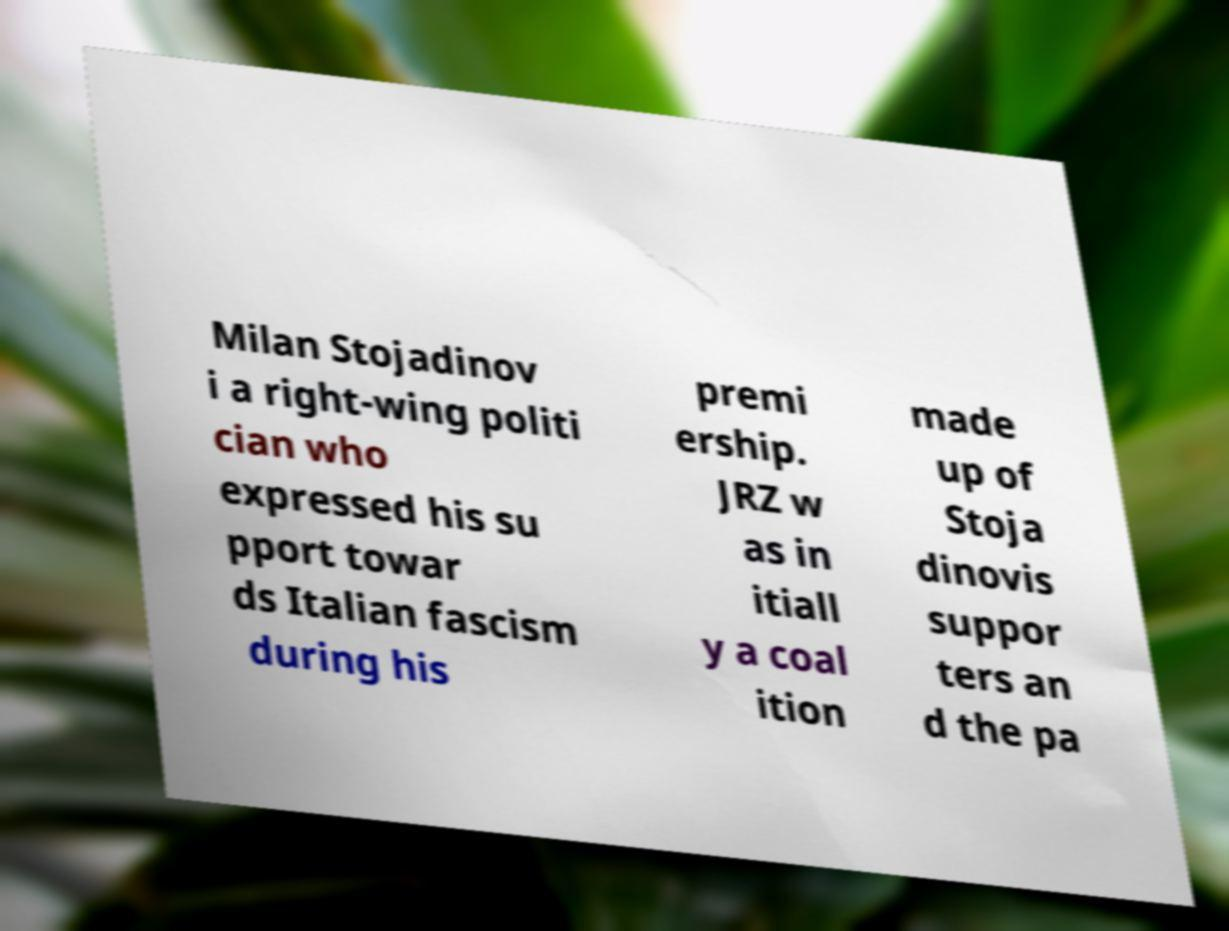Please identify and transcribe the text found in this image. Milan Stojadinov i a right-wing politi cian who expressed his su pport towar ds Italian fascism during his premi ership. JRZ w as in itiall y a coal ition made up of Stoja dinovis suppor ters an d the pa 